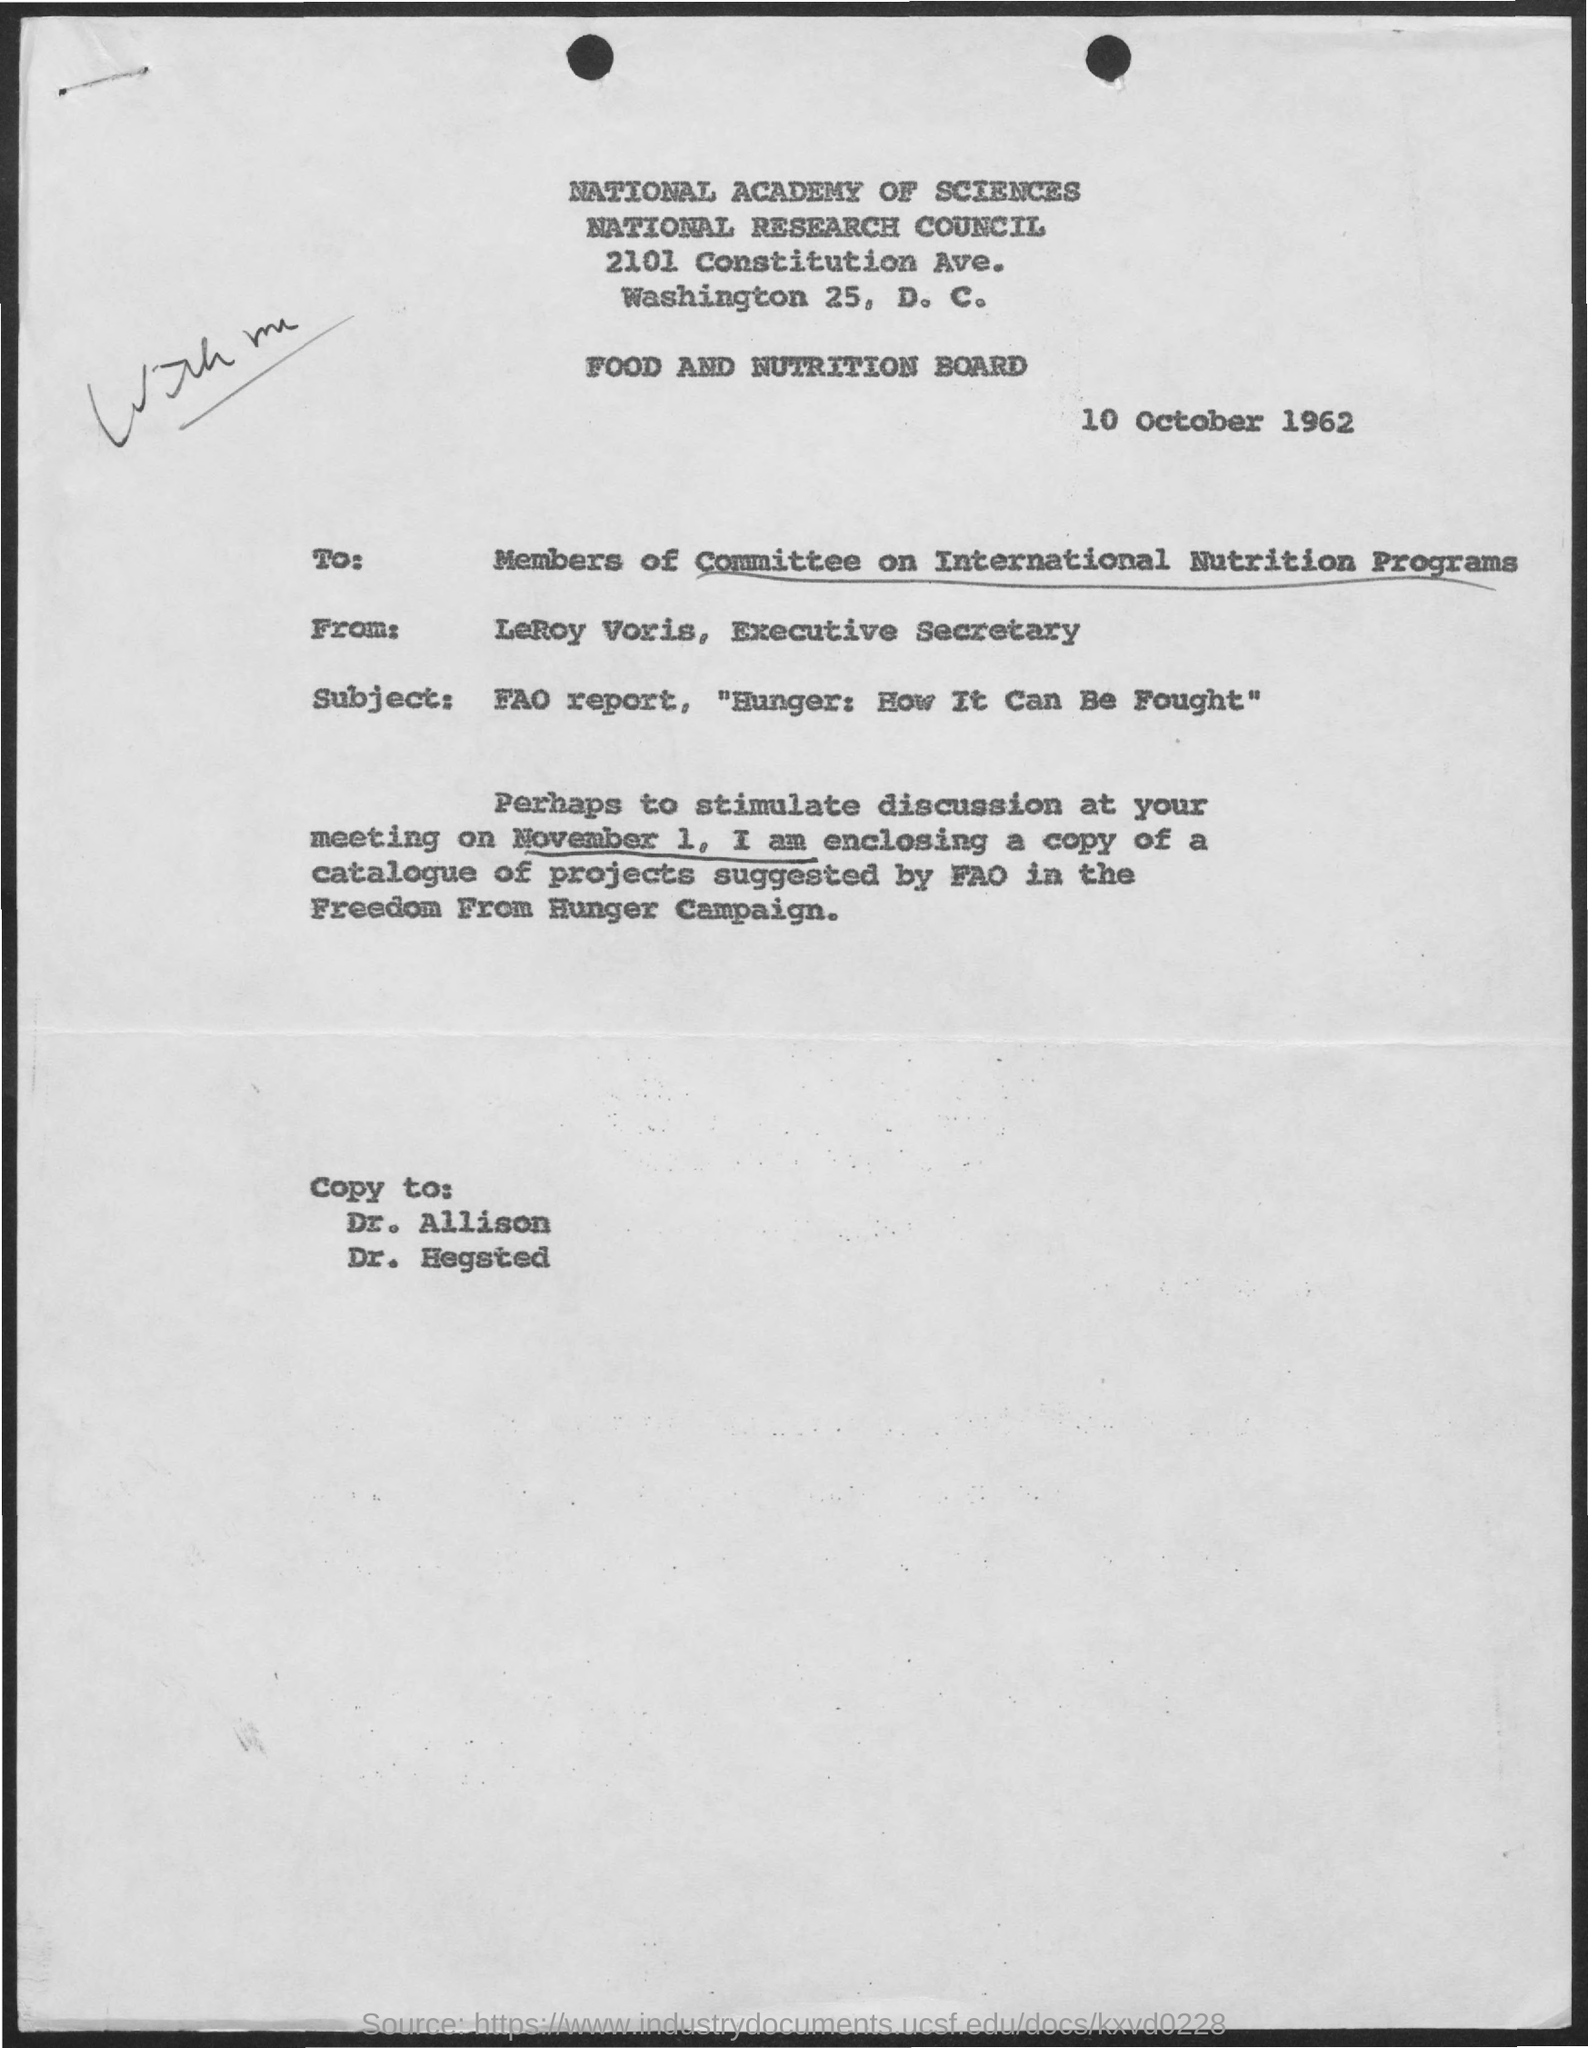Mention a couple of crucial points in this snapshot. The subject mentioned in this letter is "Hunger: How It Can Be Fought," which is a report produced by the Food and Agriculture Organization (FAO). The recipients of this letter are the members of the Committee on International Nutrition Programs. The sender of this letter is LeRoy Voris, the Executive Secretary. The letter is dated October 10th, 1962. 